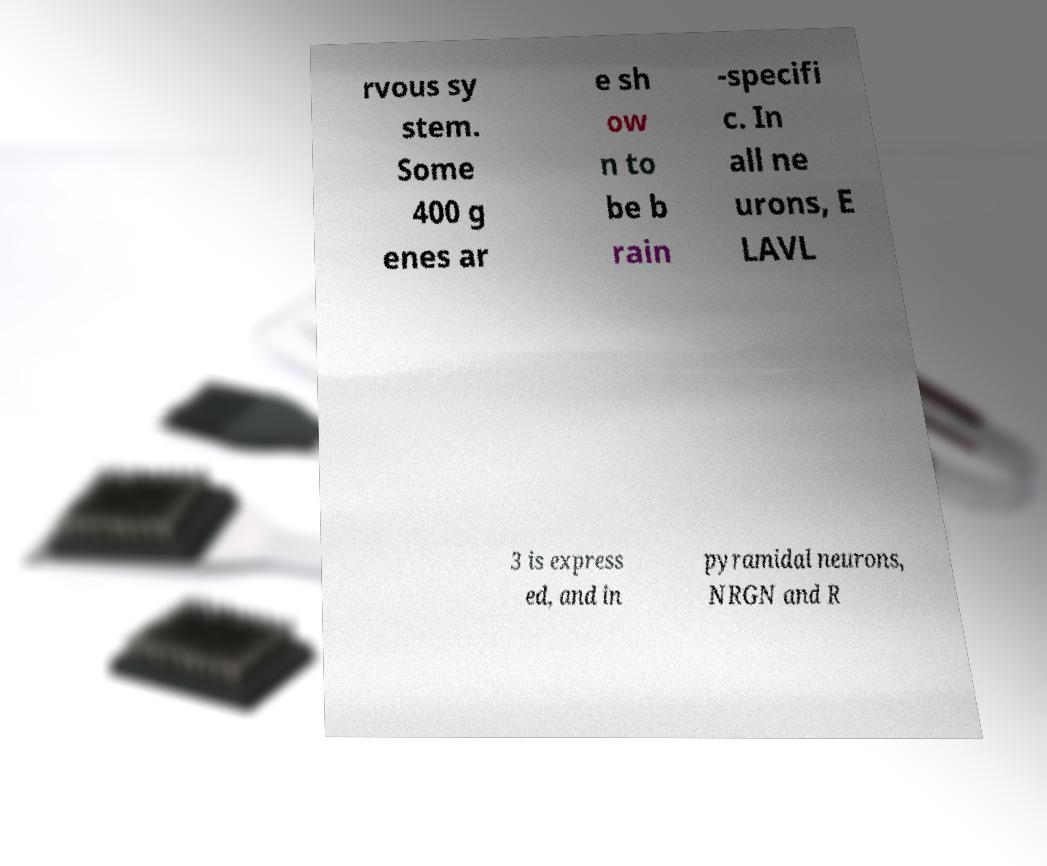Can you read and provide the text displayed in the image?This photo seems to have some interesting text. Can you extract and type it out for me? rvous sy stem. Some 400 g enes ar e sh ow n to be b rain -specifi c. In all ne urons, E LAVL 3 is express ed, and in pyramidal neurons, NRGN and R 